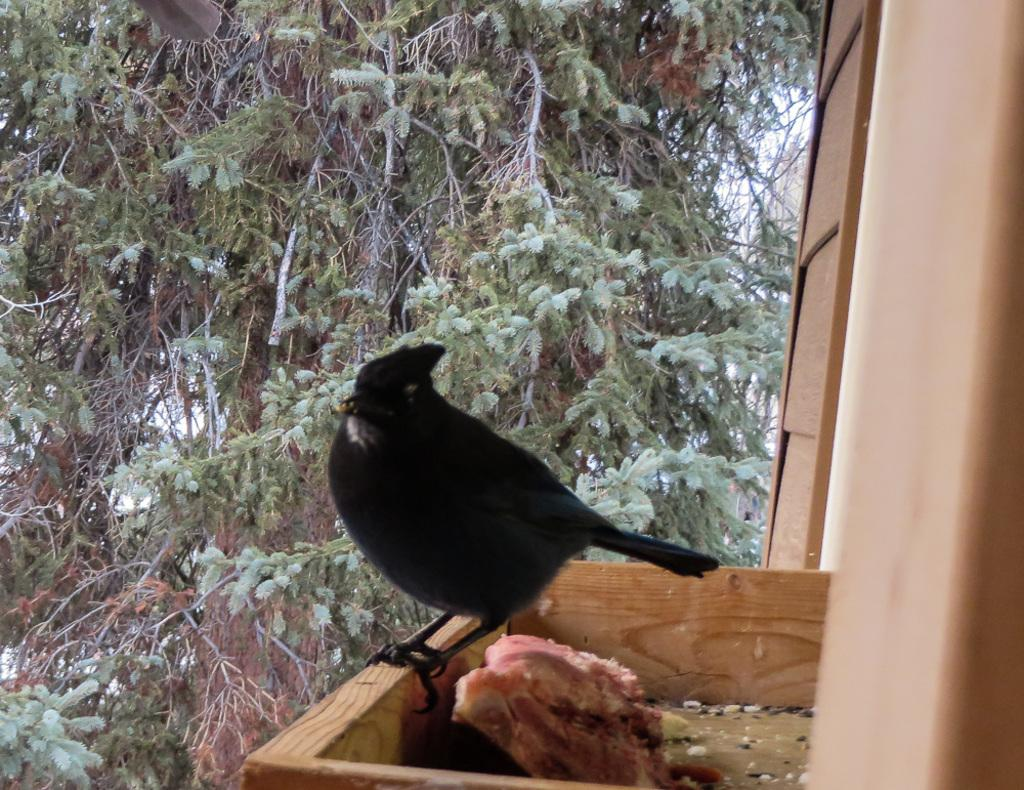What is the main subject in the center of the image? There is a bird in the center of the image. What else can be seen in the image besides the bird? There is a wooden box with food in the image. What can be seen in the background of the image? There is a tree in the background of the image. What is on the right side of the image? There is a wooden wall on the right side of the image. What type of eggnog is being served to the boy in the image? There is no boy or eggnog present in the image; it features a bird, a wooden box with food, a tree in the background, and a wooden wall on the right side. 